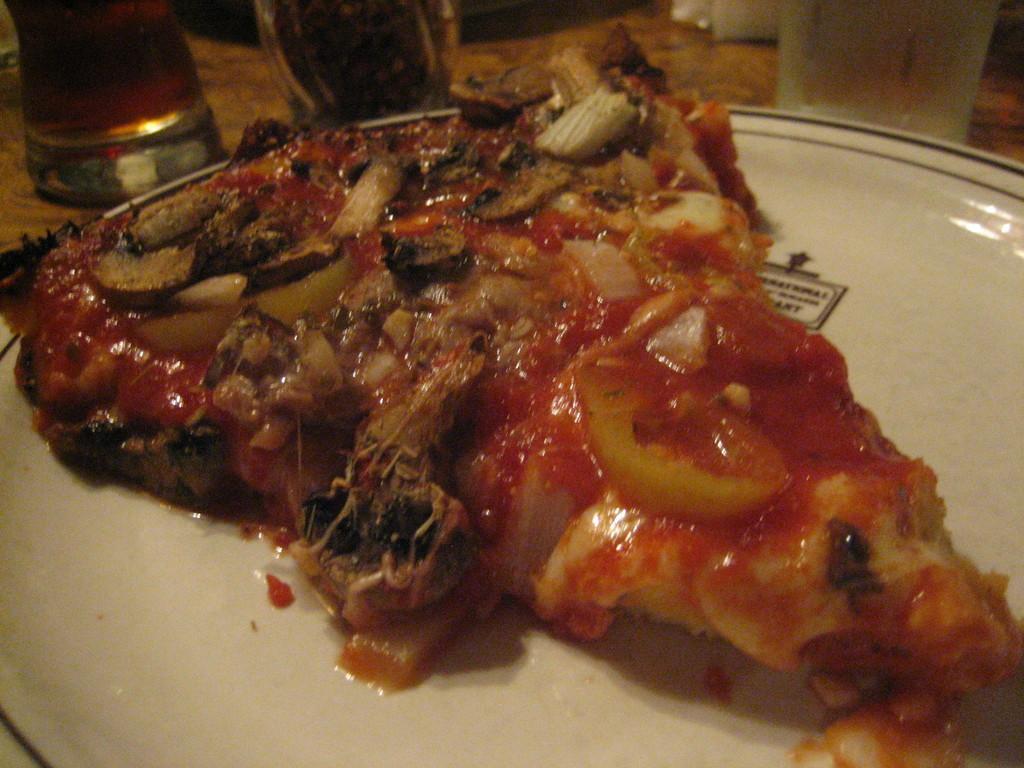In one or two sentences, can you explain what this image depicts? In this image we can see some food on the plate. There are few drink glasses placed on the wooden surface. 